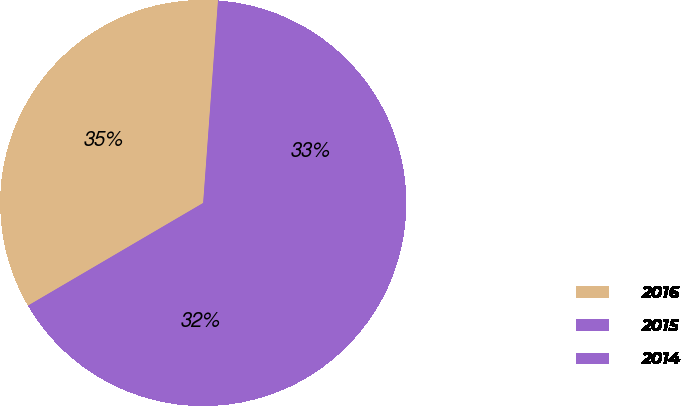Convert chart to OTSL. <chart><loc_0><loc_0><loc_500><loc_500><pie_chart><fcel>2016<fcel>2015<fcel>2014<nl><fcel>34.6%<fcel>33.26%<fcel>32.14%<nl></chart> 